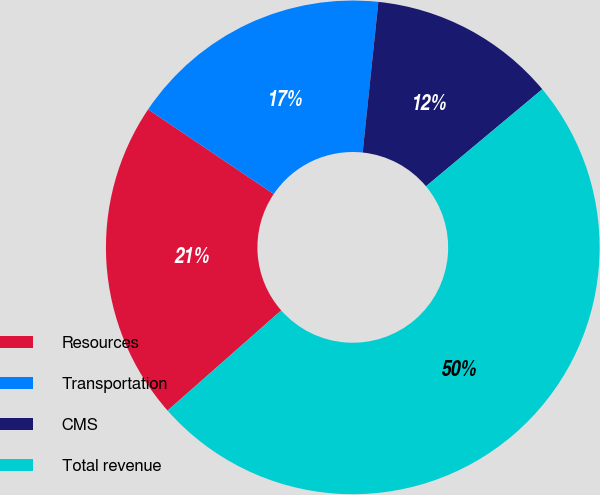Convert chart to OTSL. <chart><loc_0><loc_0><loc_500><loc_500><pie_chart><fcel>Resources<fcel>Transportation<fcel>CMS<fcel>Total revenue<nl><fcel>20.94%<fcel>17.21%<fcel>12.28%<fcel>49.57%<nl></chart> 